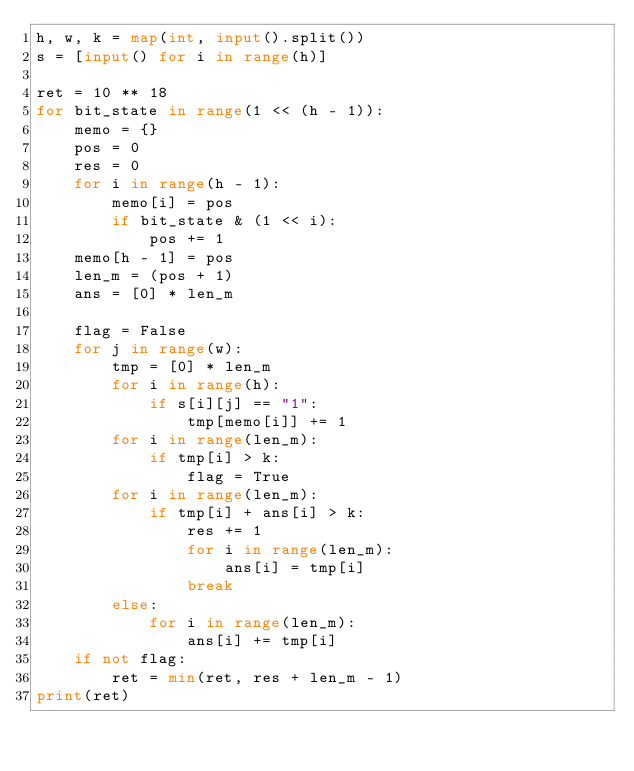<code> <loc_0><loc_0><loc_500><loc_500><_Python_>h, w, k = map(int, input().split())
s = [input() for i in range(h)]

ret = 10 ** 18
for bit_state in range(1 << (h - 1)):
    memo = {}
    pos = 0
    res = 0
    for i in range(h - 1):
        memo[i] = pos
        if bit_state & (1 << i):
            pos += 1
    memo[h - 1] = pos
    len_m = (pos + 1)
    ans = [0] * len_m
    
    flag = False
    for j in range(w):
        tmp = [0] * len_m
        for i in range(h):
            if s[i][j] == "1":
                tmp[memo[i]] += 1
        for i in range(len_m):
            if tmp[i] > k:
                flag = True
        for i in range(len_m):
            if tmp[i] + ans[i] > k:
                res += 1
                for i in range(len_m):
                    ans[i] = tmp[i]
                break
        else:
            for i in range(len_m):
                ans[i] += tmp[i]
    if not flag:
        ret = min(ret, res + len_m - 1)
print(ret)</code> 